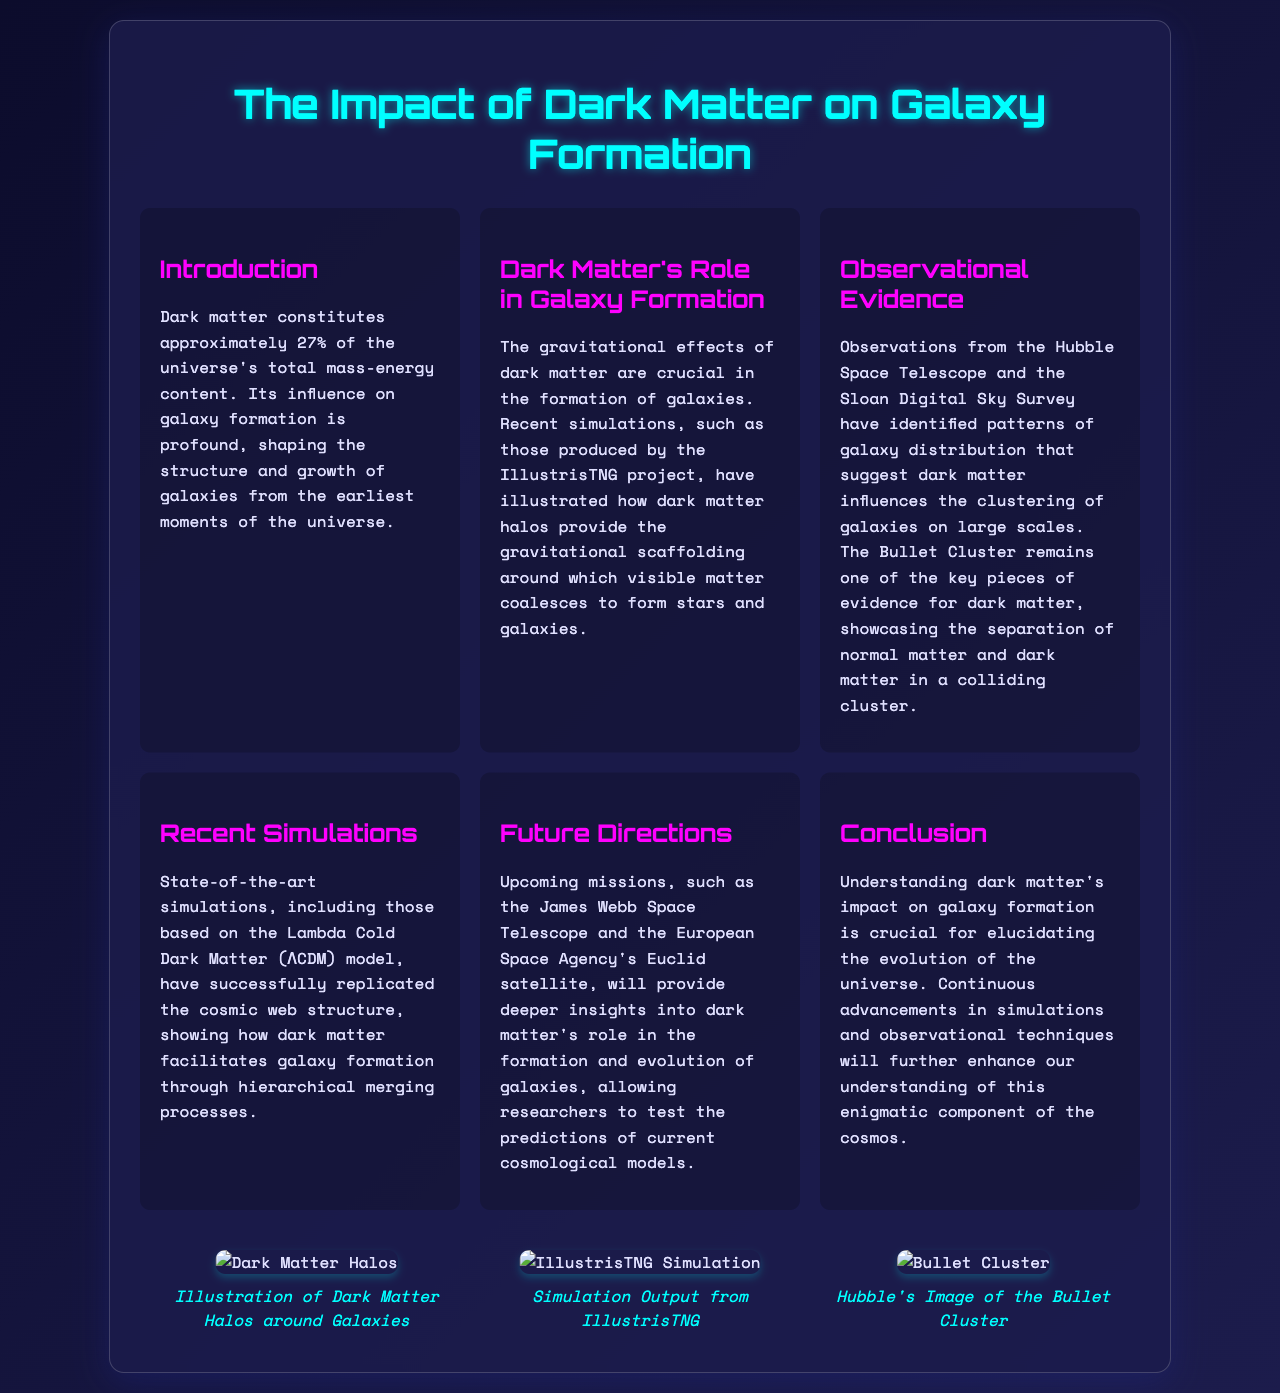What percentage of the universe's total mass-energy content is dark matter? The document states that dark matter constitutes approximately 27% of the universe's total mass-energy content.
Answer: 27% What is one key observational piece of evidence for dark matter? The document mentions the Bullet Cluster as one of the key pieces of evidence for dark matter.
Answer: Bullet Cluster Which simulation project is highlighted for illustrating dark matter halos? The document references the IllustrisTNG project as illustrating how dark matter halos provide gravitational scaffolding.
Answer: IllustrisTNG What model do recent simulations predominantly use? The document indicates that recent simulations are based on the Lambda Cold Dark Matter (ΛCDM) model.
Answer: ΛCDM What upcoming telescope is mentioned in relation to studying dark matter? The document states that the James Webb Space Telescope will provide deeper insights into dark matter's role in galaxy formation.
Answer: James Webb Space Telescope What concept does dark matter facilitate through hierarchical merging? The document suggests that dark matter facilitates the process of galaxy formation through hierarchical merging processes.
Answer: Galaxy formation Which telescope's observations are discussed in relation to galaxy clustering? The document mentions observations from the Hubble Space Telescope concerning galaxy clustering.
Answer: Hubble Space Telescope In which section is the impact of dark matter on galaxy evolution discussed? The document discusses dark matter’s impact on galaxy evolution in the "Conclusion" section.
Answer: Conclusion 